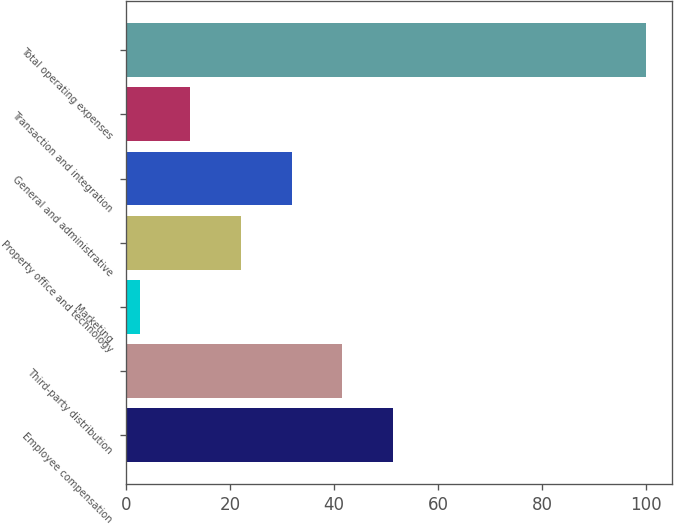Convert chart to OTSL. <chart><loc_0><loc_0><loc_500><loc_500><bar_chart><fcel>Employee compensation<fcel>Third-party distribution<fcel>Marketing<fcel>Property office and technology<fcel>General and administrative<fcel>Transaction and integration<fcel>Total operating expenses<nl><fcel>51.35<fcel>41.62<fcel>2.7<fcel>22.16<fcel>31.89<fcel>12.43<fcel>100<nl></chart> 